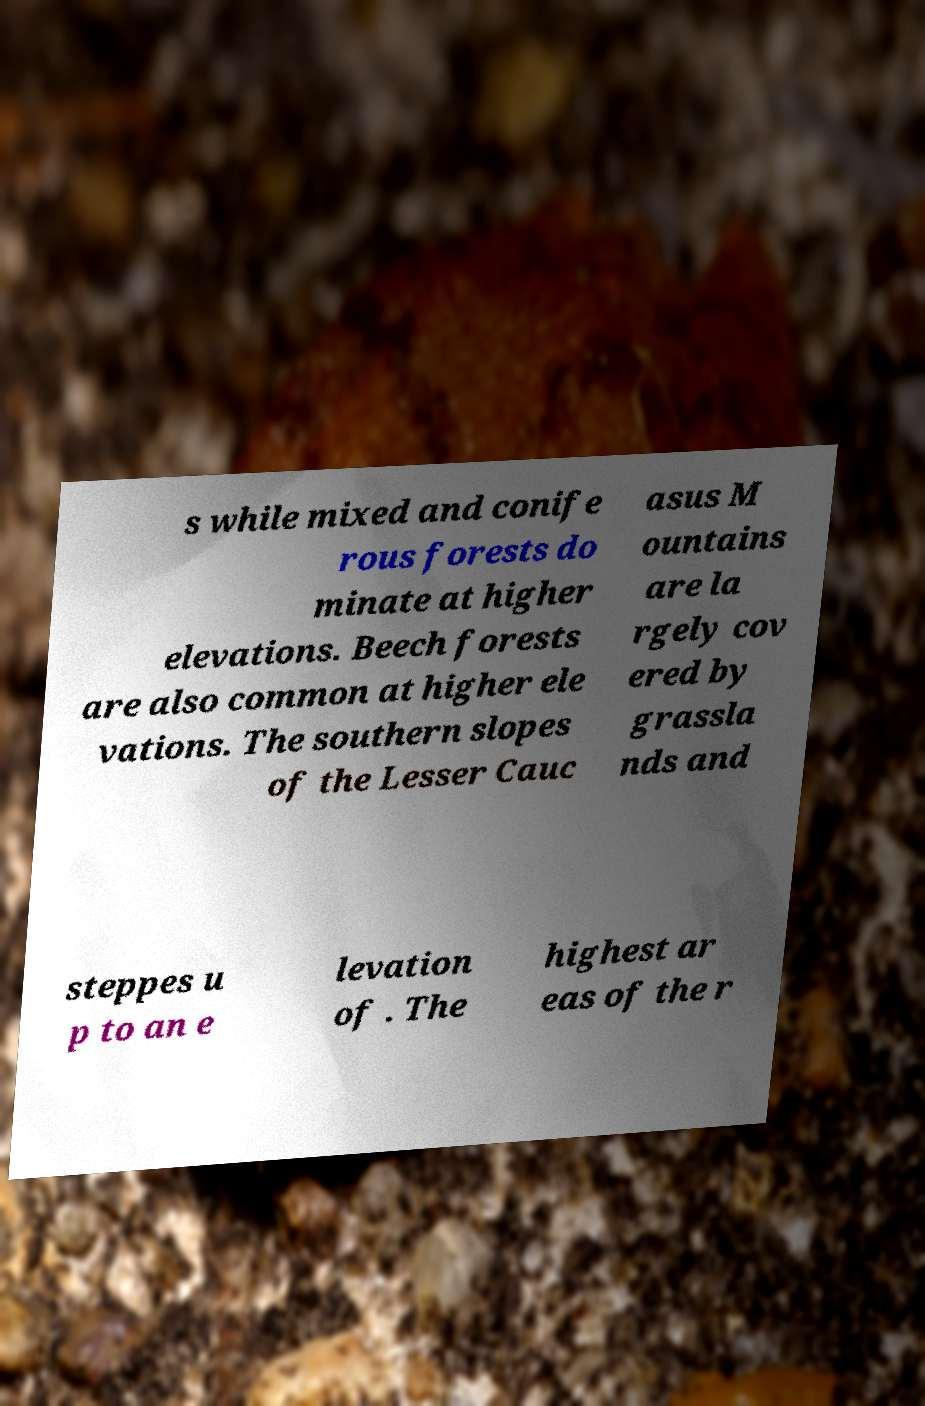Could you extract and type out the text from this image? s while mixed and conife rous forests do minate at higher elevations. Beech forests are also common at higher ele vations. The southern slopes of the Lesser Cauc asus M ountains are la rgely cov ered by grassla nds and steppes u p to an e levation of . The highest ar eas of the r 